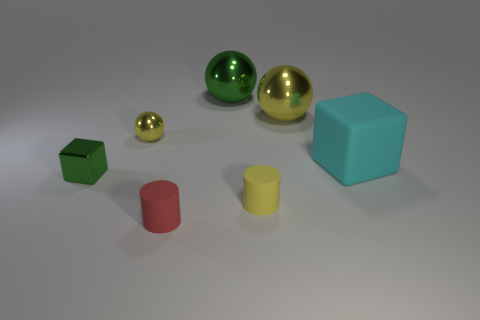How does the lighting in the scene affect the appearance of the objects? The lighting in the scene casts soft shadows and gives the objects a gentle glow, emphasizing their glossy textures and making the colors appear more vivid. 